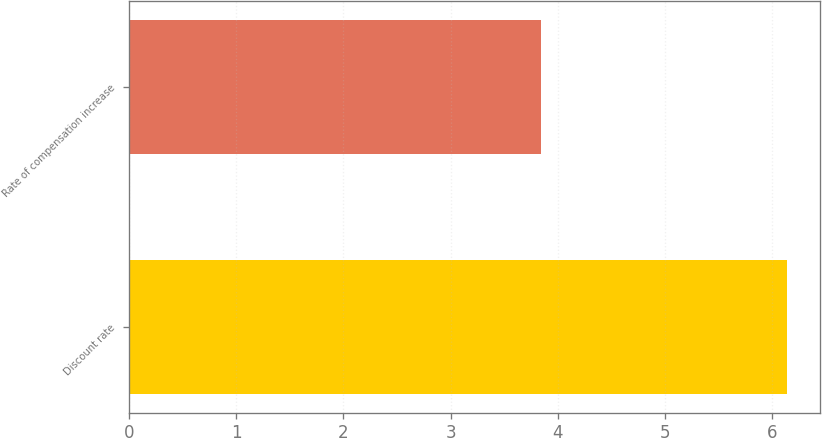<chart> <loc_0><loc_0><loc_500><loc_500><bar_chart><fcel>Discount rate<fcel>Rate of compensation increase<nl><fcel>6.14<fcel>3.84<nl></chart> 